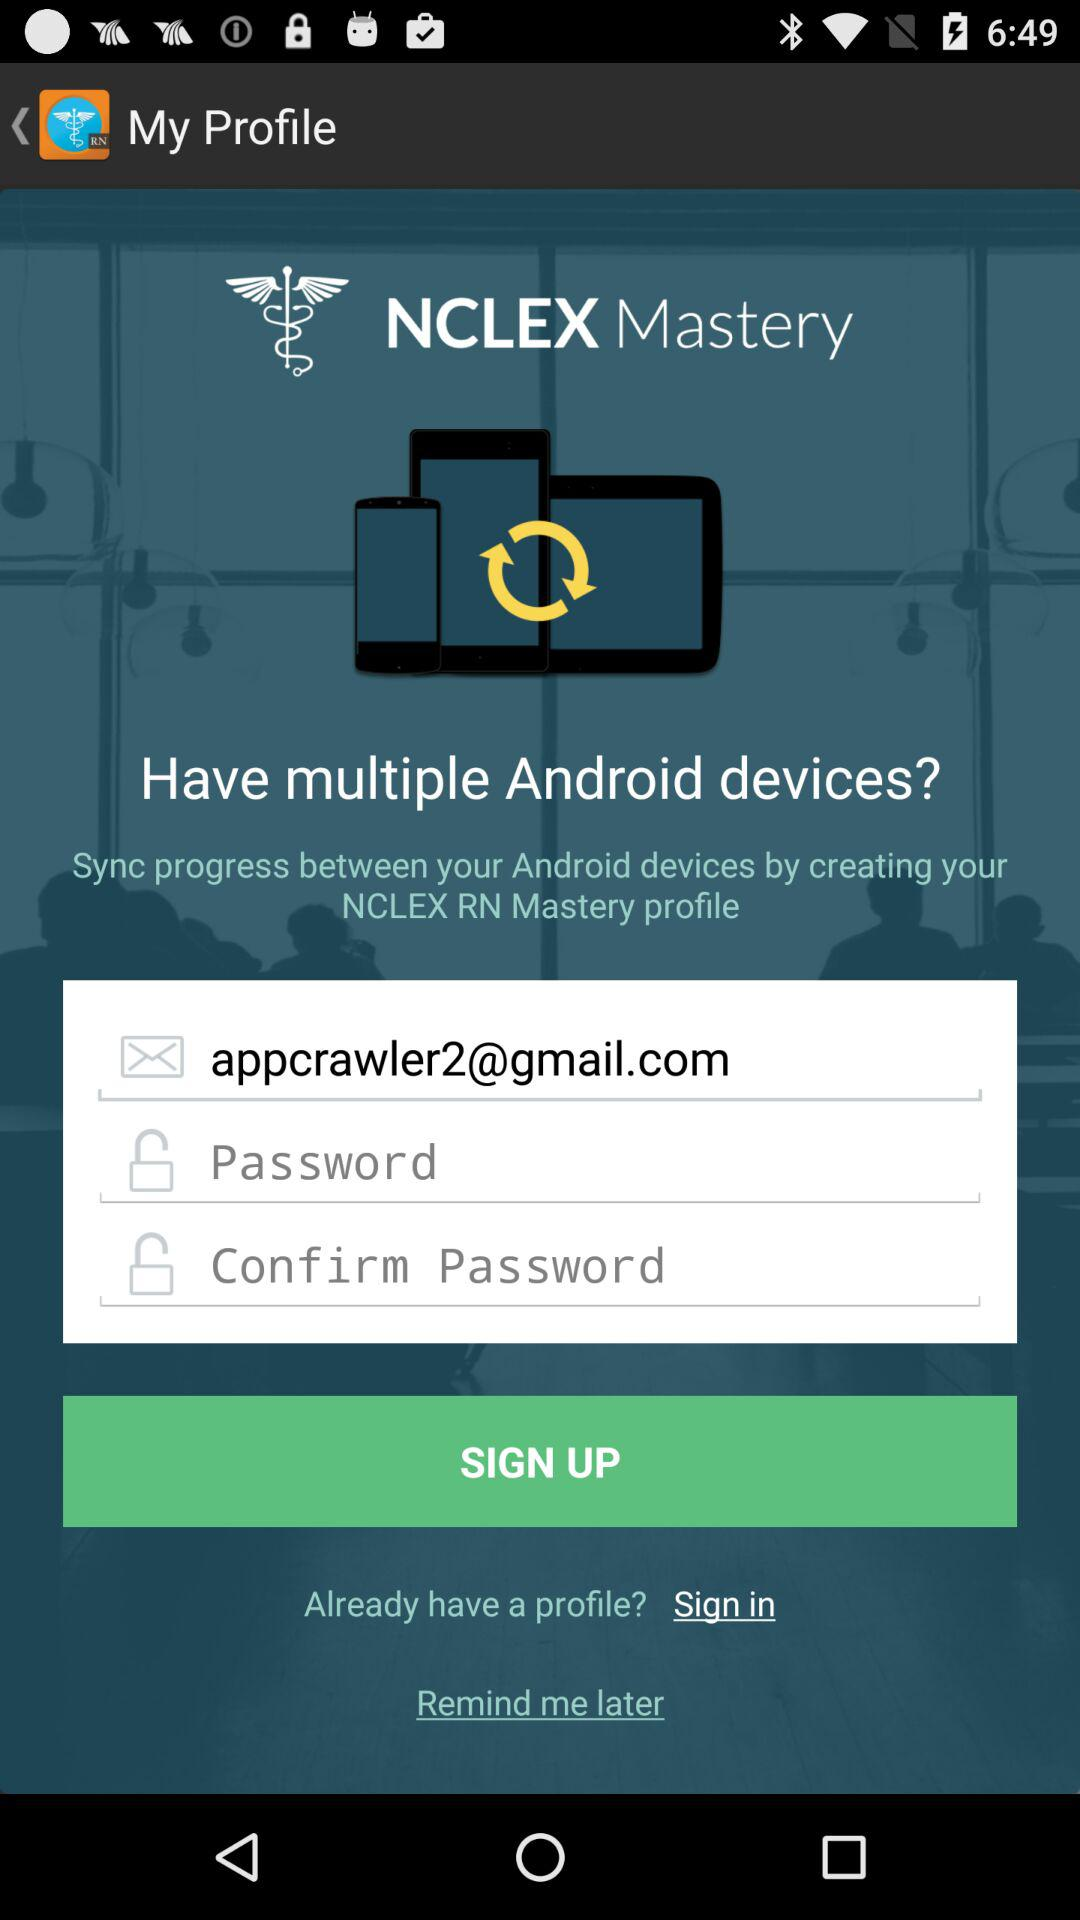How many input fields are there for creating a profile?
Answer the question using a single word or phrase. 3 